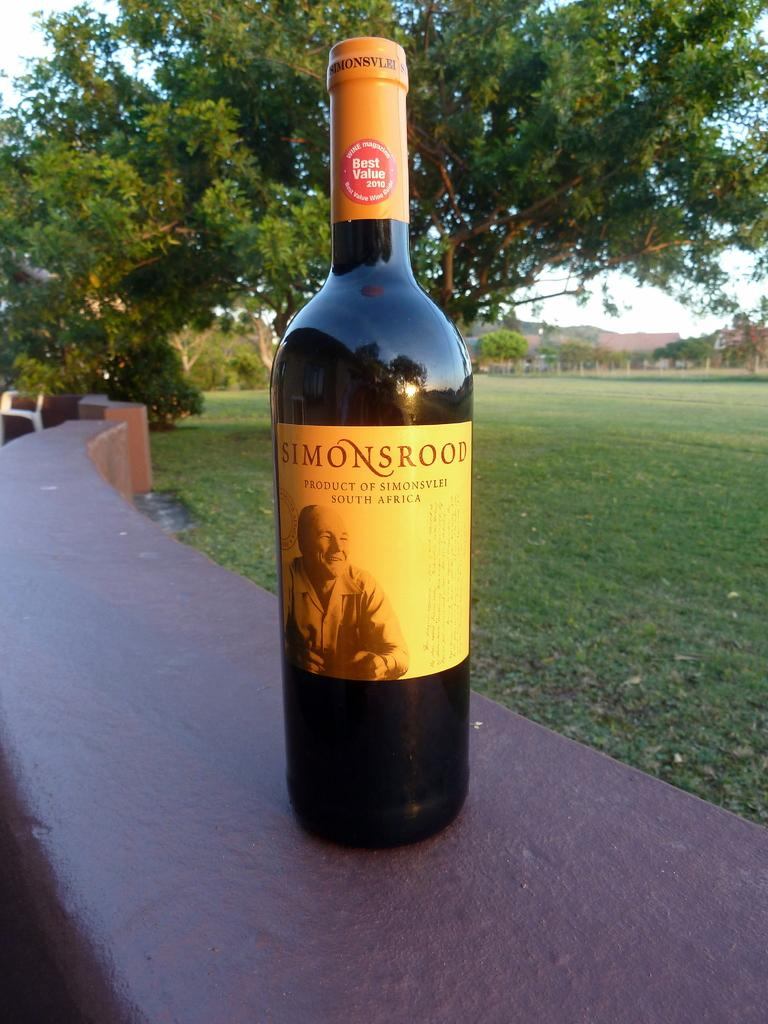<image>
Render a clear and concise summary of the photo. a wall outside has a bottle of simonsrood win on it 